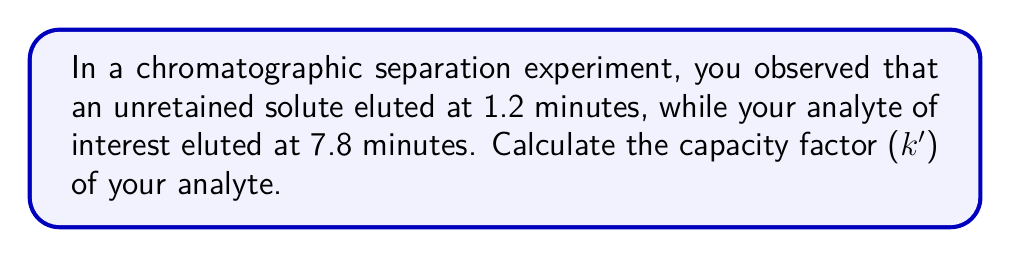Provide a solution to this math problem. To solve this problem, we need to use the formula for the capacity factor (k') in chromatography:

$$ k' = \frac{t_R - t_0}{t_0} $$

Where:
$t_R$ = retention time of the analyte
$t_0$ = retention time of an unretained solute (also known as void time or dead time)

Given:
$t_0 = 1.2$ minutes
$t_R = 7.8$ minutes

Let's substitute these values into the equation:

$$ k' = \frac{7.8 - 1.2}{1.2} $$

$$ k' = \frac{6.6}{1.2} $$

Now, let's perform the division:

$$ k' = 5.5 $$

The capacity factor is a dimensionless quantity, so we don't need to include units in our final answer.
Answer: $k' = 5.5$ 